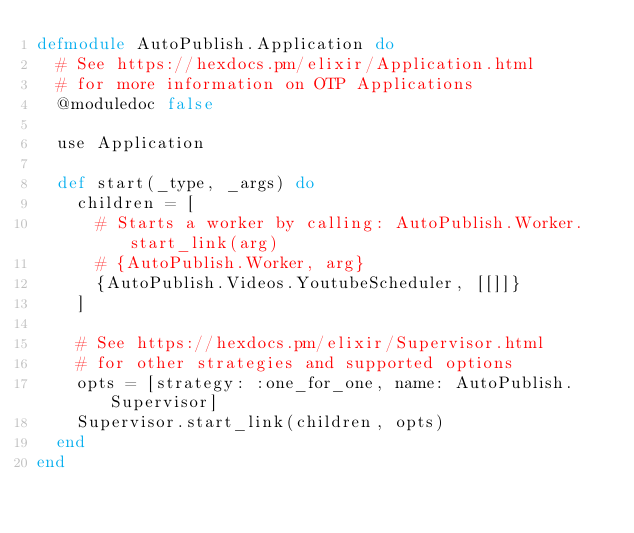<code> <loc_0><loc_0><loc_500><loc_500><_Elixir_>defmodule AutoPublish.Application do
  # See https://hexdocs.pm/elixir/Application.html
  # for more information on OTP Applications
  @moduledoc false

  use Application

  def start(_type, _args) do
    children = [
      # Starts a worker by calling: AutoPublish.Worker.start_link(arg)
      # {AutoPublish.Worker, arg}
      {AutoPublish.Videos.YoutubeScheduler, [[]]}
    ]

    # See https://hexdocs.pm/elixir/Supervisor.html
    # for other strategies and supported options
    opts = [strategy: :one_for_one, name: AutoPublish.Supervisor]
    Supervisor.start_link(children, opts)
  end
end
</code> 